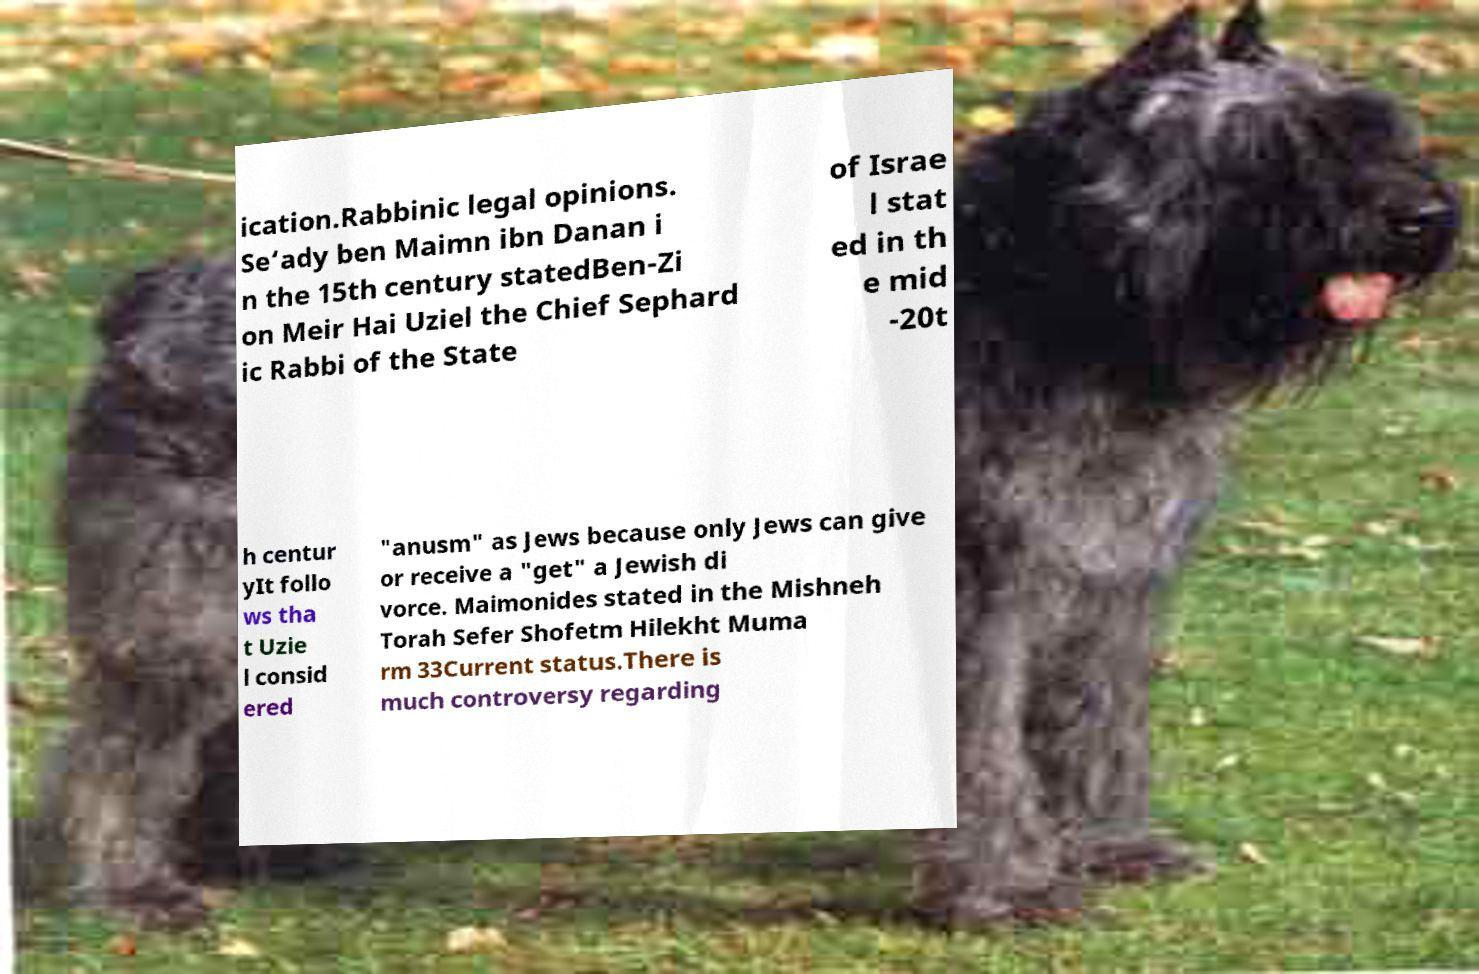For documentation purposes, I need the text within this image transcribed. Could you provide that? ication.Rabbinic legal opinions. Se‘ady ben Maimn ibn Danan i n the 15th century statedBen-Zi on Meir Hai Uziel the Chief Sephard ic Rabbi of the State of Israe l stat ed in th e mid -20t h centur yIt follo ws tha t Uzie l consid ered "anusm" as Jews because only Jews can give or receive a "get" a Jewish di vorce. Maimonides stated in the Mishneh Torah Sefer Shofetm Hilekht Muma rm 33Current status.There is much controversy regarding 